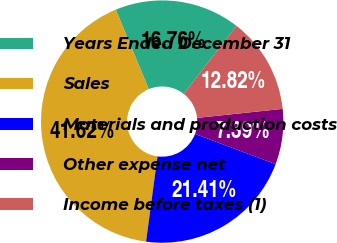<chart> <loc_0><loc_0><loc_500><loc_500><pie_chart><fcel>Years Ended December 31<fcel>Sales<fcel>Materials and production costs<fcel>Other expense net<fcel>Income before taxes (1)<nl><fcel>16.76%<fcel>41.62%<fcel>21.41%<fcel>7.39%<fcel>12.82%<nl></chart> 